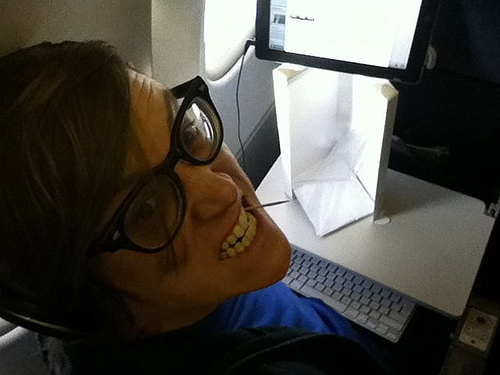Imagine the guy is writing a novel. What could be the possible plot? The novel could center around a tech-savvy adventurer who travels the world collecting rare artifacts and uses advanced gadgets to solve ancient mysteries. 